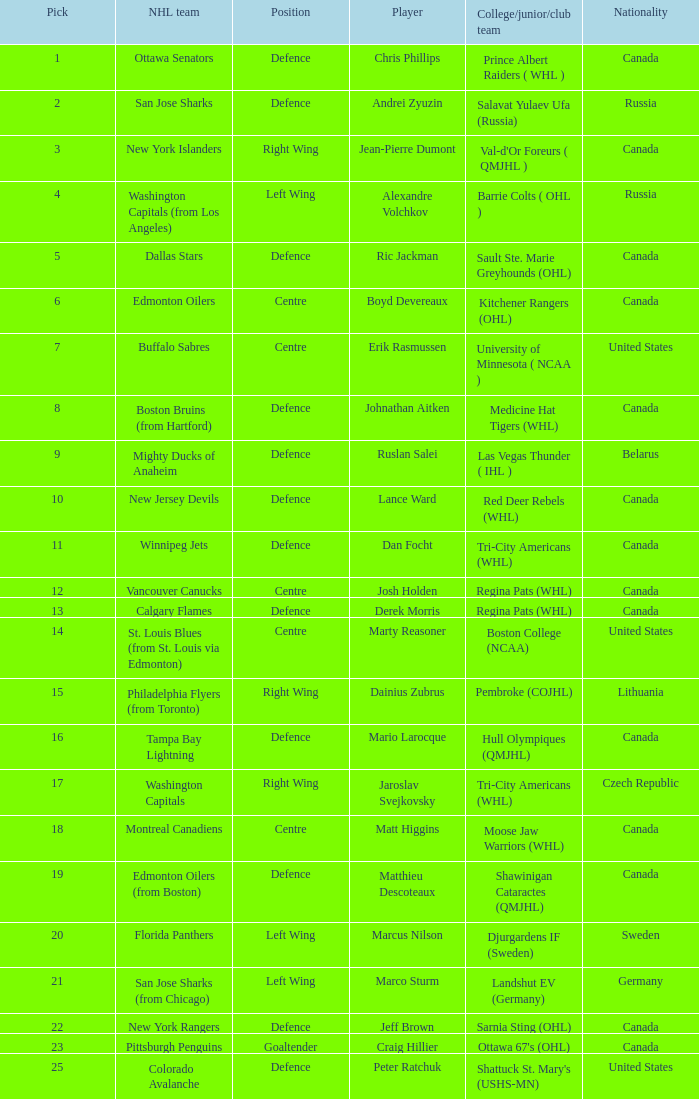What draft pick number was Ric Jackman? 5.0. 